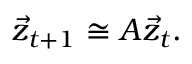Convert formula to latex. <formula><loc_0><loc_0><loc_500><loc_500>\vec { z } _ { t + 1 } \cong A \vec { z } _ { t } .</formula> 